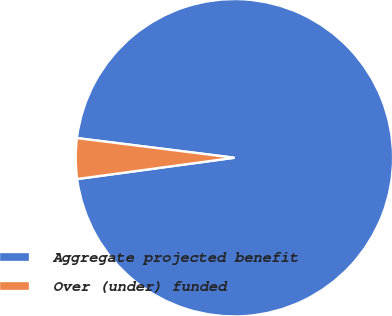Convert chart. <chart><loc_0><loc_0><loc_500><loc_500><pie_chart><fcel>Aggregate projected benefit<fcel>Over (under) funded<nl><fcel>95.88%<fcel>4.12%<nl></chart> 